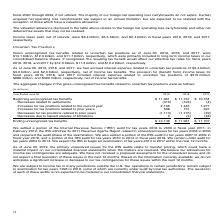According to Microsoft Corporation's financial document, When does the company expect the IRS to begin an examination of tax years 2014 to 2017? We expect the IRS to begin an examination of tax years 2014 to 2017 within the next 12 months.. The document states: "We remain under audit for tax years 2004 to 2013. We expect the IRS to begin an examination of tax years 2014 to 2017 within the next 12 months...." Also, When did the IRS withdraw the 2011 Revenue Agents Report? In February 2012, the IRS withdrew its 2011 Revenue Agents Report related to unresolved issues for tax years 2004 to 2006 and reopened the audit phase of the examination.. The document states: "it for tax years 2004 to 2006 in fiscal year 2011. In February 2012, the IRS withdrew its 2011 Revenue Agents Report related to unresolved issues for ..." Also, How much was the accrued interest expense related to uncertain tax positions as of June 30, 2019? As of June 30, 2019, 2018, and 2017, we had accrued interest expense related to uncertain tax positions of $3.4 billion, $3.0 billion, and $2.3 billion, respectively, net of income tax benefits.. The document states: "As of June 30, 2019, 2018, and 2017, we had accrued interest expense related to uncertain tax positions of $3.4 billion, $3.0 billion, and $2.3 billio..." Also, How many years between 2017 and 2019 had ending unrecognized tax benefits of over $12,000 million? Based on the analysis, there are 1 instances. The counting process: 13,146. Also, How many years between 2017 and 2019 had Increases for tax positions related to prior years that were greater than 100million? Counting the relevant items in the document: 508, 151, 397, I find 3 instances. The key data points involved are: 151, 397, 508. Additionally, Which of the 3 years had the highest ending unrecognized tax benefits? According to the financial document, 2019. The relevant text states: "Year Ended June 30, 2019 2018 2017..." 